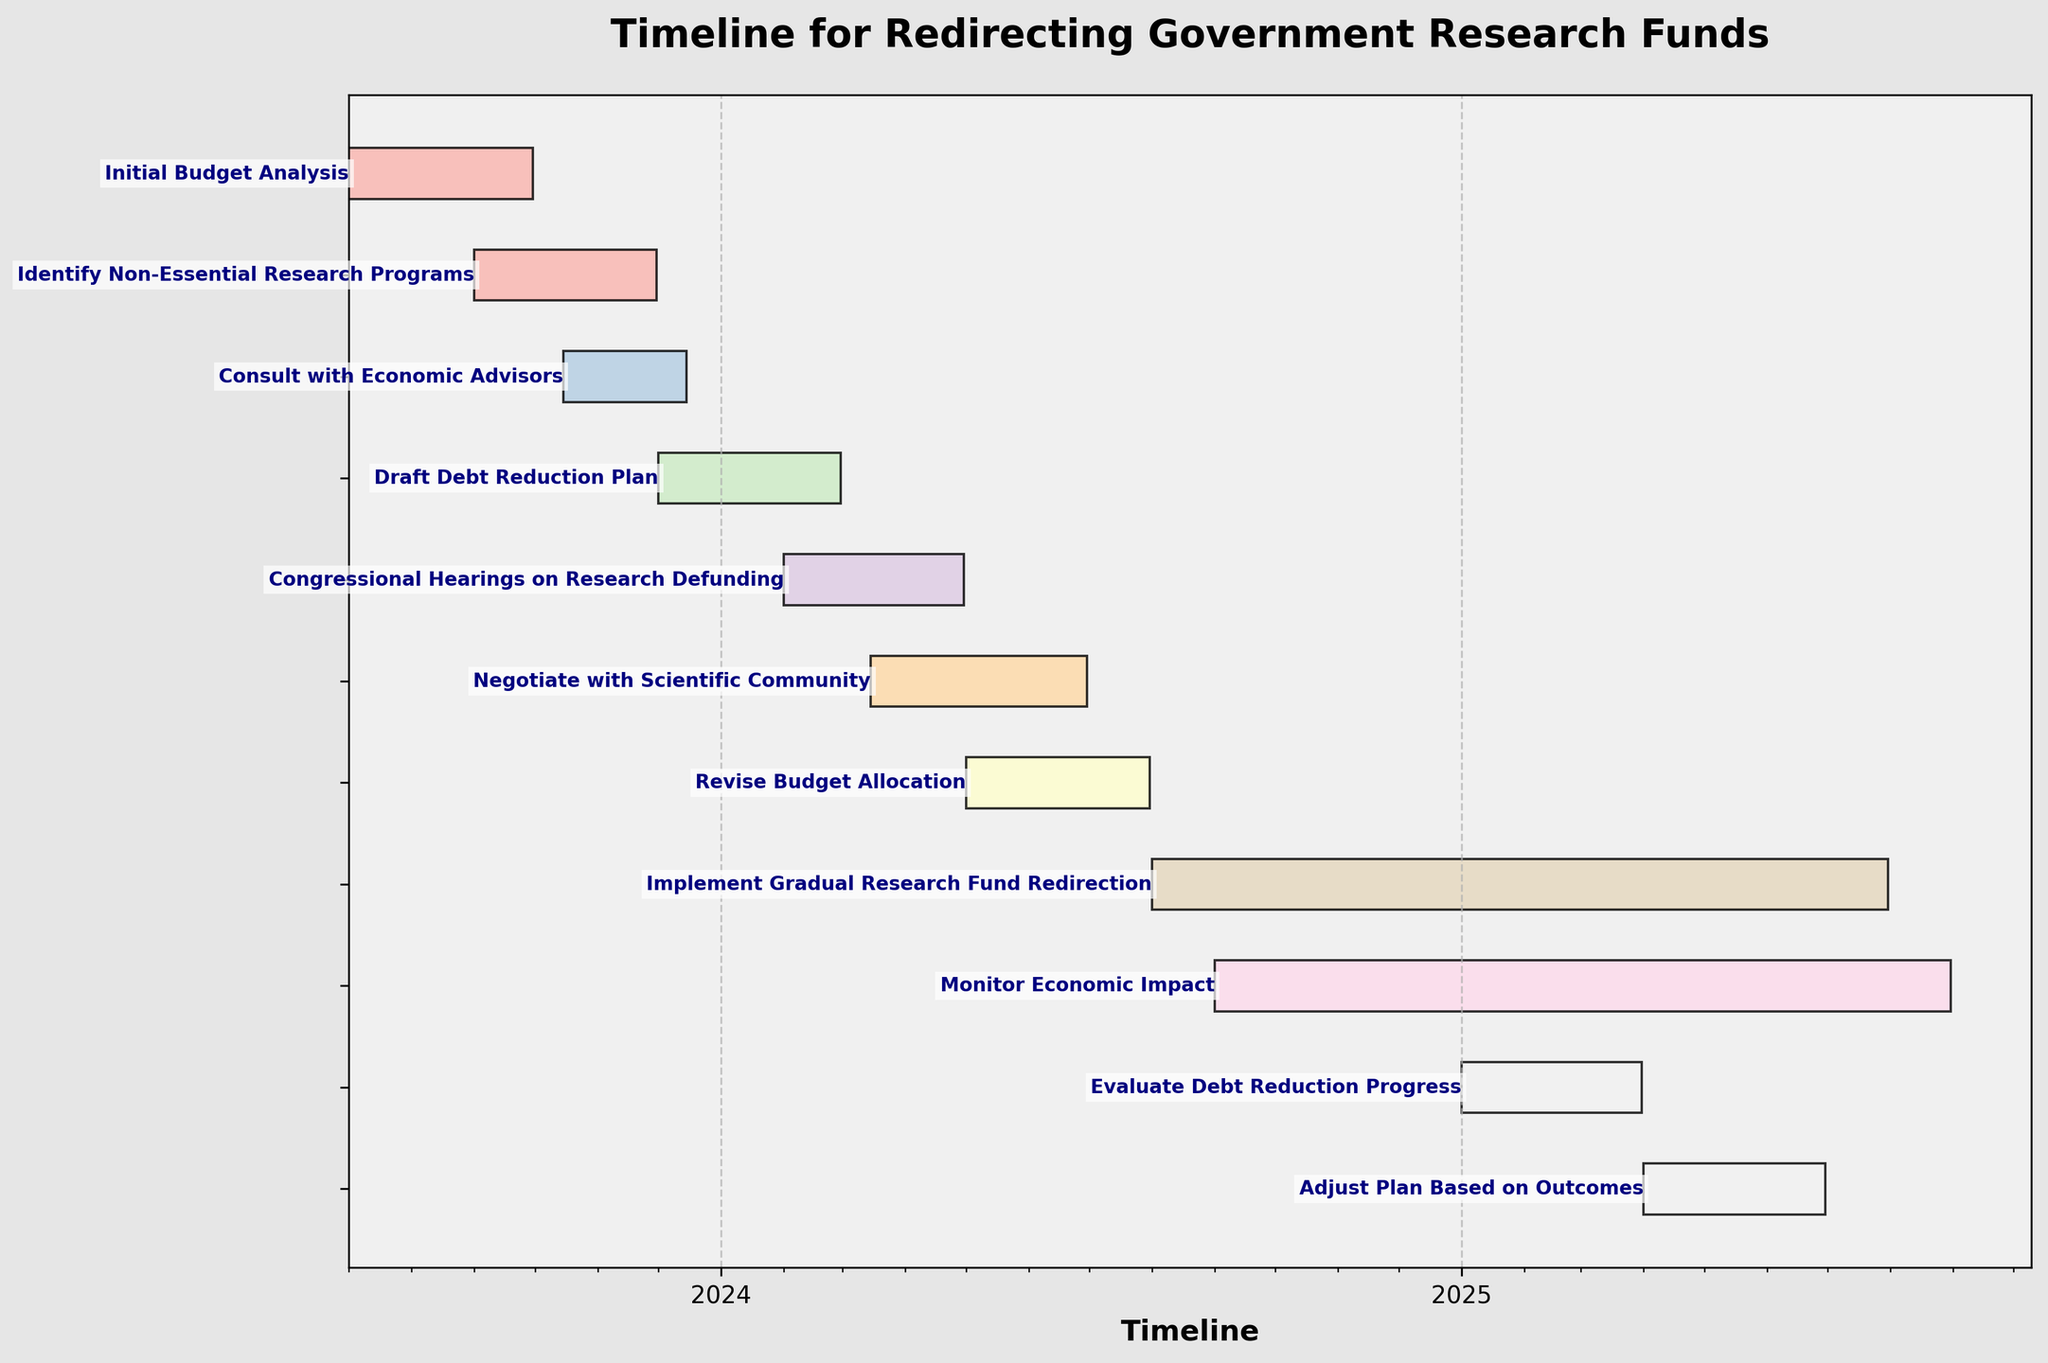What is the title of the Gantt chart? The title is usually displayed prominently at the top of the chart. It often summarizes the main focus or topic of the chart.
Answer: Timeline for Redirecting Government Research Funds How many tasks are shown in the Gantt chart? Each task in the Gantt chart has its own horizontal bar. Count the number of bars to determine the number of tasks.
Answer: 11 When does the "Monitor Economic Impact" task start? The start date of a task is shown at the left end of its corresponding horizontal bar. Locate the bar for "Monitor Economic Impact" to find its start date.
Answer: 2024-09-01 Which task starts immediately after "Identify Non-Essential Research Programs"? Look at the timeline position of "Identify Non-Essential Research Programs". The task whose start date follows right after its end date is the next task.
Answer: Consult with Economic Advisors How long does the "Draft Debt Reduction Plan" task take? The task duration can be calculated by subtracting the start date from the end date of the task. The dates are shown at each end of the task's horizontal bar.
Answer: 91 days Which tasks have overlapping time periods with "Consult with Economic Advisors"? Identify the time period for "Consult with Economic Advisors" by its start and end dates. Check for other tasks whose time periods overlap with this range.
Answer: Identify Non-Essential Research Programs, Draft Debt Reduction Plan What is the shortest task in the Gantt chart? Compare the durations of all tasks by observing the length of each bar. The shortest bar represents the shortest task.
Answer: Evaluate Debt Reduction Progress How many tasks are scheduled to take place in the year 2025? Locate tasks that have start or end dates within the year 2025 by examining their timeline positions. Count these tasks.
Answer: 4 When does the task "Evaluate Debt Reduction Progress" end? The end date of a task is shown at the right end of its corresponding horizontal bar. Locate the bar for "Evaluate Debt Reduction Progress" to find its end date.
Answer: 2025-03-31 Which task has the longest duration? Compare the durations of all tasks by observing the length of their bars. The longest bar represents the task with the longest duration.
Answer: Implement Gradual Research Fund Redirection 